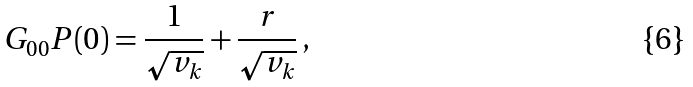<formula> <loc_0><loc_0><loc_500><loc_500>G _ { 0 0 } P ( 0 ) = \frac { 1 } { \sqrt { v _ { k } } } + \frac { r } { \sqrt { v _ { k } } } \, ,</formula> 